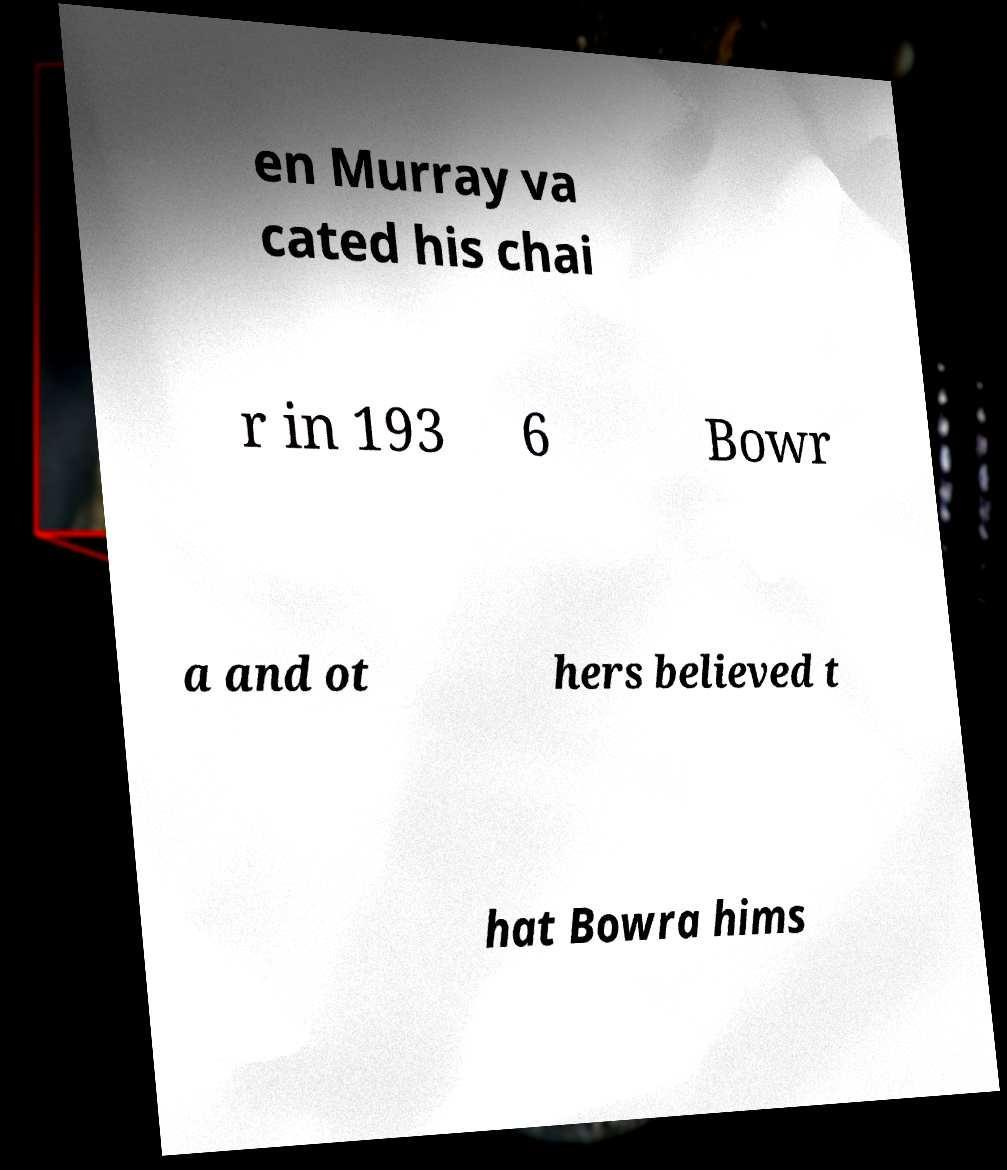Please read and relay the text visible in this image. What does it say? en Murray va cated his chai r in 193 6 Bowr a and ot hers believed t hat Bowra hims 